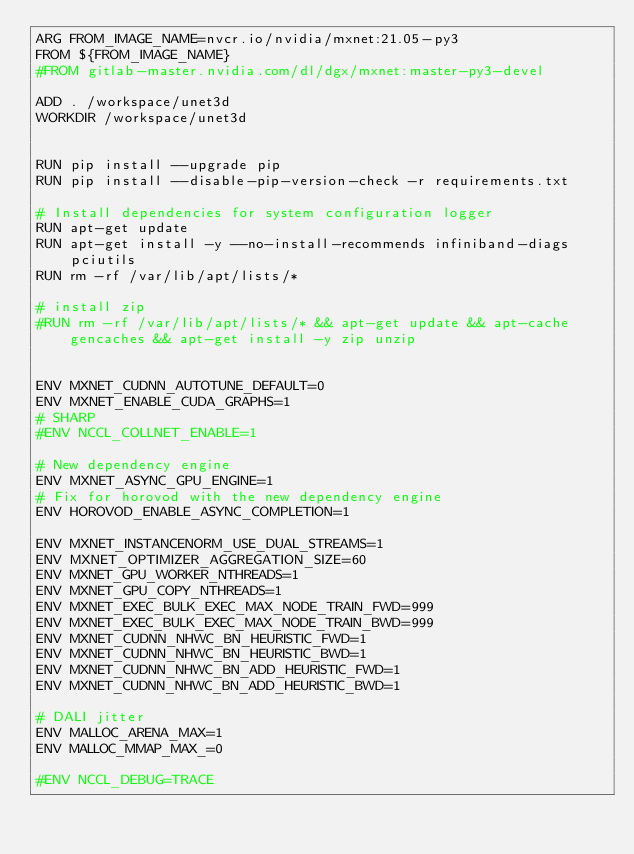<code> <loc_0><loc_0><loc_500><loc_500><_Dockerfile_>ARG FROM_IMAGE_NAME=nvcr.io/nvidia/mxnet:21.05-py3
FROM ${FROM_IMAGE_NAME}
#FROM gitlab-master.nvidia.com/dl/dgx/mxnet:master-py3-devel

ADD . /workspace/unet3d
WORKDIR /workspace/unet3d


RUN pip install --upgrade pip
RUN pip install --disable-pip-version-check -r requirements.txt

# Install dependencies for system configuration logger
RUN apt-get update
RUN apt-get install -y --no-install-recommends infiniband-diags pciutils
RUN rm -rf /var/lib/apt/lists/*

# install zip
#RUN rm -rf /var/lib/apt/lists/* && apt-get update && apt-cache gencaches && apt-get install -y zip unzip


ENV MXNET_CUDNN_AUTOTUNE_DEFAULT=0
ENV MXNET_ENABLE_CUDA_GRAPHS=1
# SHARP
#ENV NCCL_COLLNET_ENABLE=1

# New dependency engine
ENV MXNET_ASYNC_GPU_ENGINE=1
# Fix for horovod with the new dependency engine
ENV HOROVOD_ENABLE_ASYNC_COMPLETION=1

ENV MXNET_INSTANCENORM_USE_DUAL_STREAMS=1
ENV MXNET_OPTIMIZER_AGGREGATION_SIZE=60
ENV MXNET_GPU_WORKER_NTHREADS=1
ENV MXNET_GPU_COPY_NTHREADS=1
ENV MXNET_EXEC_BULK_EXEC_MAX_NODE_TRAIN_FWD=999
ENV MXNET_EXEC_BULK_EXEC_MAX_NODE_TRAIN_BWD=999
ENV MXNET_CUDNN_NHWC_BN_HEURISTIC_FWD=1
ENV MXNET_CUDNN_NHWC_BN_HEURISTIC_BWD=1
ENV MXNET_CUDNN_NHWC_BN_ADD_HEURISTIC_FWD=1
ENV MXNET_CUDNN_NHWC_BN_ADD_HEURISTIC_BWD=1

# DALI jitter
ENV MALLOC_ARENA_MAX=1
ENV MALLOC_MMAP_MAX_=0

#ENV NCCL_DEBUG=TRACE

</code> 